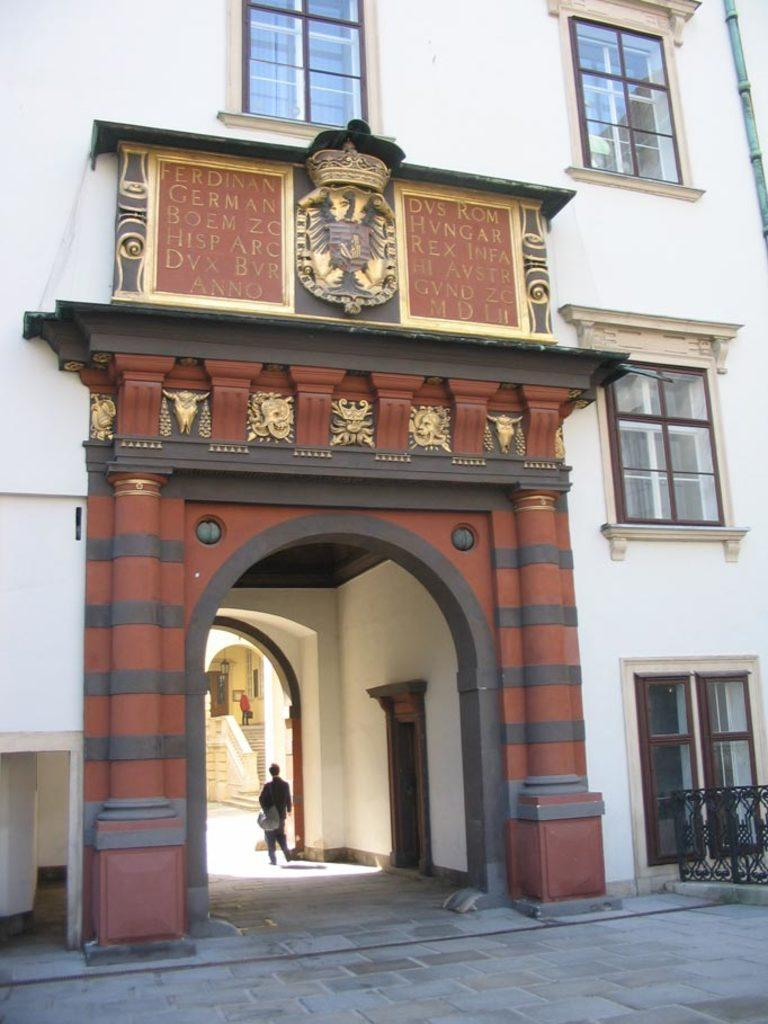What type of structure is visible in the image? There is a building in the image. What materials can be seen in the image? There are boards visible in the image. What architectural features are present in the building? There are windows and doors in the image. How many people are in the image? There are two people in the image. Can you recall the memory of the lizards walking on the building in the image? There are no lizards present in the image, and therefore no memory of them walking on the building can be recalled. 